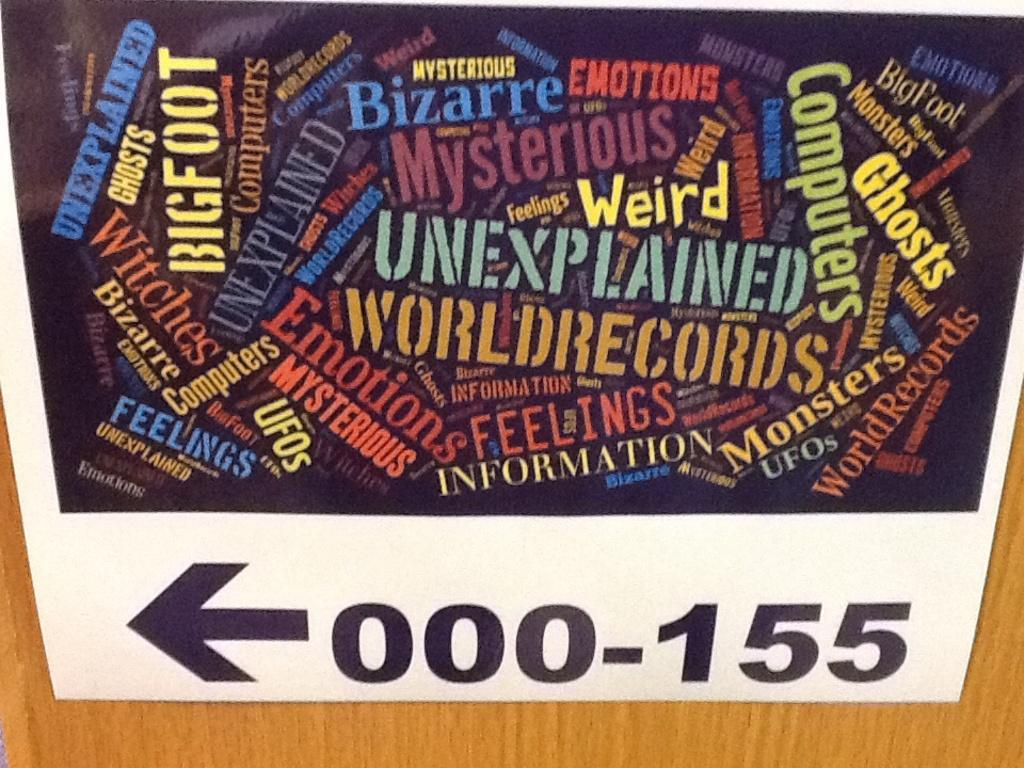<image>
Share a concise interpretation of the image provided. An arrow pointing to the left indicates that there you can find 000-155. 